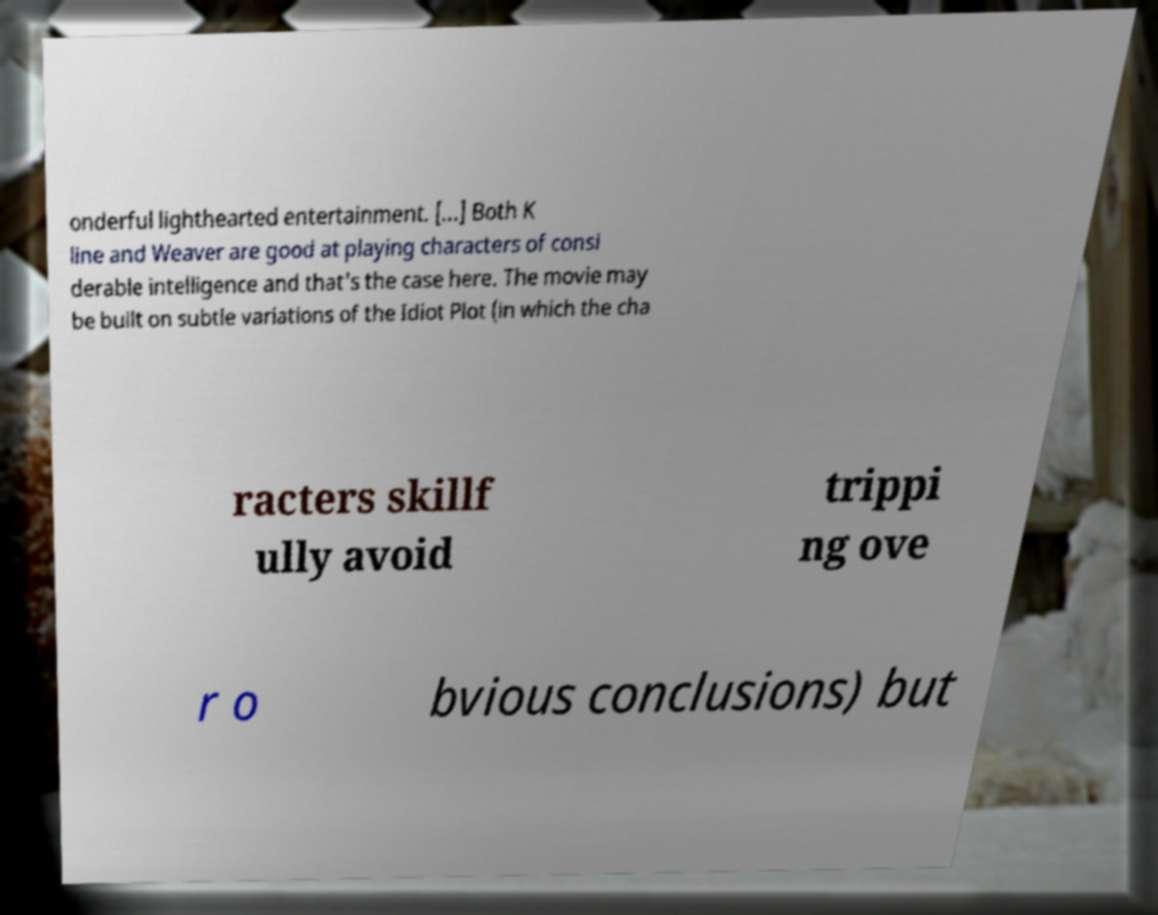Please identify and transcribe the text found in this image. onderful lighthearted entertainment. [...] Both K line and Weaver are good at playing characters of consi derable intelligence and that's the case here. The movie may be built on subtle variations of the Idiot Plot (in which the cha racters skillf ully avoid trippi ng ove r o bvious conclusions) but 